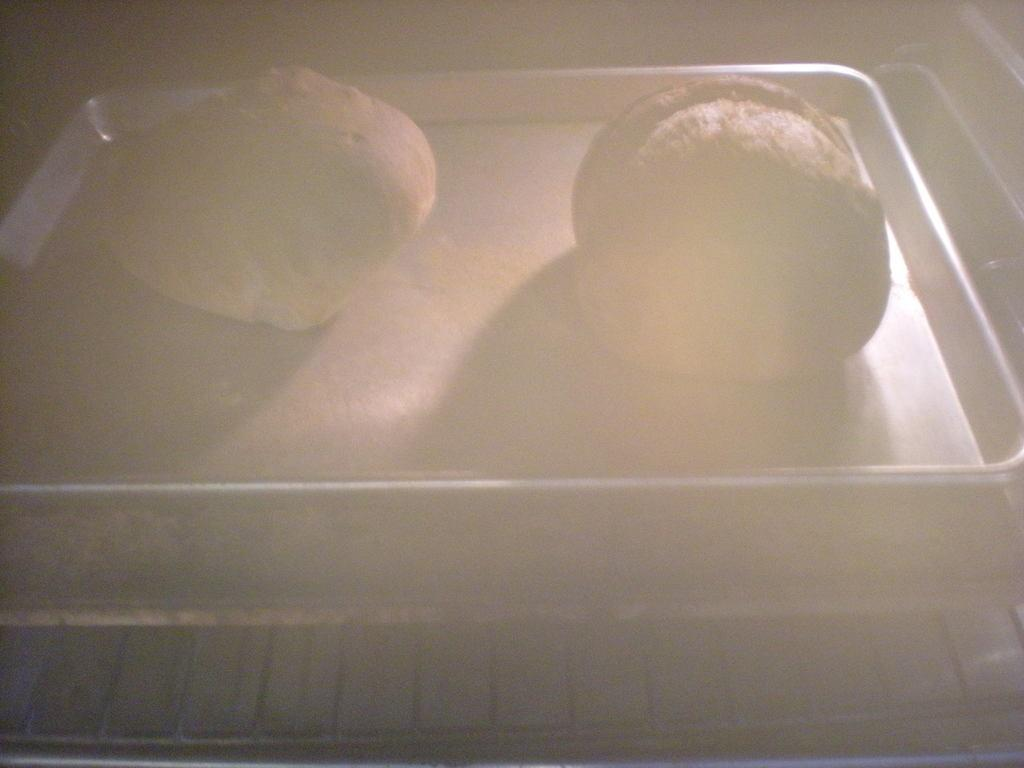What is on the tray that is visible in the image? There is food on a tray in the image. What type of cooking appliance is at the bottom of the image? There is a grill at the bottom of the image. What type of jeans are being worn by the grill in the image? There are no jeans present in the image, as the grill is an inanimate object and cannot wear clothing. How many toes can be seen on the rail in the image? There is no rail or toes present in the image; it only features food on a tray and a grill. 